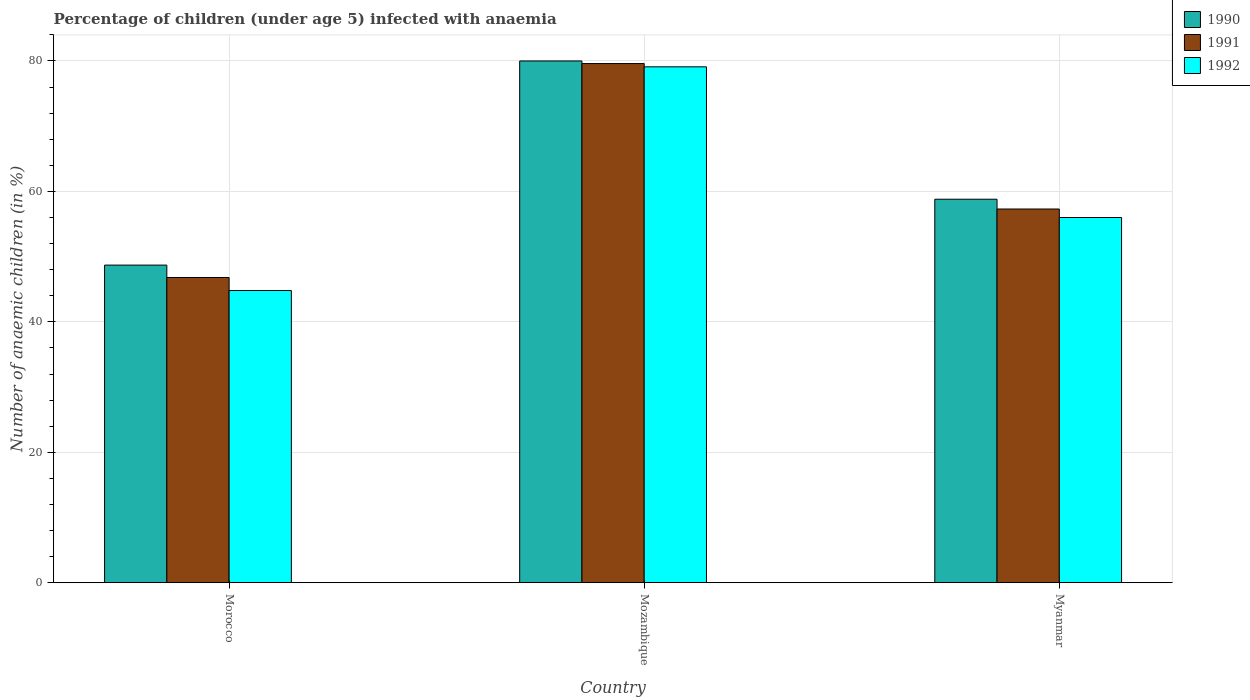How many groups of bars are there?
Your response must be concise. 3. Are the number of bars on each tick of the X-axis equal?
Provide a succinct answer. Yes. How many bars are there on the 1st tick from the right?
Your answer should be compact. 3. What is the label of the 2nd group of bars from the left?
Your answer should be very brief. Mozambique. What is the percentage of children infected with anaemia in in 1992 in Mozambique?
Keep it short and to the point. 79.1. Across all countries, what is the maximum percentage of children infected with anaemia in in 1992?
Make the answer very short. 79.1. Across all countries, what is the minimum percentage of children infected with anaemia in in 1991?
Ensure brevity in your answer.  46.8. In which country was the percentage of children infected with anaemia in in 1991 maximum?
Your answer should be very brief. Mozambique. In which country was the percentage of children infected with anaemia in in 1990 minimum?
Your response must be concise. Morocco. What is the total percentage of children infected with anaemia in in 1992 in the graph?
Offer a very short reply. 179.9. What is the difference between the percentage of children infected with anaemia in in 1990 in Morocco and that in Mozambique?
Give a very brief answer. -31.3. What is the difference between the percentage of children infected with anaemia in in 1990 in Myanmar and the percentage of children infected with anaemia in in 1992 in Mozambique?
Ensure brevity in your answer.  -20.3. What is the average percentage of children infected with anaemia in in 1992 per country?
Make the answer very short. 59.97. What is the difference between the percentage of children infected with anaemia in of/in 1990 and percentage of children infected with anaemia in of/in 1992 in Myanmar?
Your response must be concise. 2.8. What is the ratio of the percentage of children infected with anaemia in in 1992 in Morocco to that in Mozambique?
Your answer should be compact. 0.57. Is the percentage of children infected with anaemia in in 1992 in Morocco less than that in Myanmar?
Your answer should be very brief. Yes. Is the difference between the percentage of children infected with anaemia in in 1990 in Morocco and Mozambique greater than the difference between the percentage of children infected with anaemia in in 1992 in Morocco and Mozambique?
Keep it short and to the point. Yes. What is the difference between the highest and the second highest percentage of children infected with anaemia in in 1990?
Provide a short and direct response. 21.2. What is the difference between the highest and the lowest percentage of children infected with anaemia in in 1991?
Provide a short and direct response. 32.8. Is it the case that in every country, the sum of the percentage of children infected with anaemia in in 1992 and percentage of children infected with anaemia in in 1991 is greater than the percentage of children infected with anaemia in in 1990?
Your response must be concise. Yes. Are all the bars in the graph horizontal?
Offer a very short reply. No. How many countries are there in the graph?
Your response must be concise. 3. Does the graph contain any zero values?
Your answer should be very brief. No. What is the title of the graph?
Ensure brevity in your answer.  Percentage of children (under age 5) infected with anaemia. Does "2007" appear as one of the legend labels in the graph?
Provide a succinct answer. No. What is the label or title of the X-axis?
Provide a succinct answer. Country. What is the label or title of the Y-axis?
Your answer should be very brief. Number of anaemic children (in %). What is the Number of anaemic children (in %) in 1990 in Morocco?
Provide a short and direct response. 48.7. What is the Number of anaemic children (in %) of 1991 in Morocco?
Keep it short and to the point. 46.8. What is the Number of anaemic children (in %) in 1992 in Morocco?
Your answer should be very brief. 44.8. What is the Number of anaemic children (in %) of 1990 in Mozambique?
Give a very brief answer. 80. What is the Number of anaemic children (in %) in 1991 in Mozambique?
Give a very brief answer. 79.6. What is the Number of anaemic children (in %) of 1992 in Mozambique?
Provide a short and direct response. 79.1. What is the Number of anaemic children (in %) in 1990 in Myanmar?
Provide a short and direct response. 58.8. What is the Number of anaemic children (in %) of 1991 in Myanmar?
Your response must be concise. 57.3. Across all countries, what is the maximum Number of anaemic children (in %) of 1991?
Your answer should be compact. 79.6. Across all countries, what is the maximum Number of anaemic children (in %) of 1992?
Keep it short and to the point. 79.1. Across all countries, what is the minimum Number of anaemic children (in %) of 1990?
Your answer should be compact. 48.7. Across all countries, what is the minimum Number of anaemic children (in %) of 1991?
Offer a terse response. 46.8. Across all countries, what is the minimum Number of anaemic children (in %) of 1992?
Keep it short and to the point. 44.8. What is the total Number of anaemic children (in %) in 1990 in the graph?
Your answer should be compact. 187.5. What is the total Number of anaemic children (in %) in 1991 in the graph?
Your response must be concise. 183.7. What is the total Number of anaemic children (in %) of 1992 in the graph?
Provide a short and direct response. 179.9. What is the difference between the Number of anaemic children (in %) in 1990 in Morocco and that in Mozambique?
Provide a short and direct response. -31.3. What is the difference between the Number of anaemic children (in %) of 1991 in Morocco and that in Mozambique?
Offer a very short reply. -32.8. What is the difference between the Number of anaemic children (in %) in 1992 in Morocco and that in Mozambique?
Provide a succinct answer. -34.3. What is the difference between the Number of anaemic children (in %) in 1990 in Mozambique and that in Myanmar?
Keep it short and to the point. 21.2. What is the difference between the Number of anaemic children (in %) of 1991 in Mozambique and that in Myanmar?
Offer a very short reply. 22.3. What is the difference between the Number of anaemic children (in %) of 1992 in Mozambique and that in Myanmar?
Offer a terse response. 23.1. What is the difference between the Number of anaemic children (in %) in 1990 in Morocco and the Number of anaemic children (in %) in 1991 in Mozambique?
Make the answer very short. -30.9. What is the difference between the Number of anaemic children (in %) of 1990 in Morocco and the Number of anaemic children (in %) of 1992 in Mozambique?
Provide a short and direct response. -30.4. What is the difference between the Number of anaemic children (in %) in 1991 in Morocco and the Number of anaemic children (in %) in 1992 in Mozambique?
Offer a very short reply. -32.3. What is the difference between the Number of anaemic children (in %) of 1990 in Mozambique and the Number of anaemic children (in %) of 1991 in Myanmar?
Provide a short and direct response. 22.7. What is the difference between the Number of anaemic children (in %) in 1990 in Mozambique and the Number of anaemic children (in %) in 1992 in Myanmar?
Your answer should be compact. 24. What is the difference between the Number of anaemic children (in %) in 1991 in Mozambique and the Number of anaemic children (in %) in 1992 in Myanmar?
Offer a terse response. 23.6. What is the average Number of anaemic children (in %) of 1990 per country?
Provide a succinct answer. 62.5. What is the average Number of anaemic children (in %) of 1991 per country?
Offer a very short reply. 61.23. What is the average Number of anaemic children (in %) in 1992 per country?
Your response must be concise. 59.97. What is the difference between the Number of anaemic children (in %) of 1990 and Number of anaemic children (in %) of 1991 in Morocco?
Make the answer very short. 1.9. What is the difference between the Number of anaemic children (in %) of 1990 and Number of anaemic children (in %) of 1991 in Mozambique?
Keep it short and to the point. 0.4. What is the difference between the Number of anaemic children (in %) in 1990 and Number of anaemic children (in %) in 1992 in Mozambique?
Your response must be concise. 0.9. What is the difference between the Number of anaemic children (in %) in 1991 and Number of anaemic children (in %) in 1992 in Mozambique?
Your answer should be very brief. 0.5. What is the ratio of the Number of anaemic children (in %) in 1990 in Morocco to that in Mozambique?
Offer a very short reply. 0.61. What is the ratio of the Number of anaemic children (in %) in 1991 in Morocco to that in Mozambique?
Make the answer very short. 0.59. What is the ratio of the Number of anaemic children (in %) of 1992 in Morocco to that in Mozambique?
Provide a succinct answer. 0.57. What is the ratio of the Number of anaemic children (in %) in 1990 in Morocco to that in Myanmar?
Provide a short and direct response. 0.83. What is the ratio of the Number of anaemic children (in %) in 1991 in Morocco to that in Myanmar?
Ensure brevity in your answer.  0.82. What is the ratio of the Number of anaemic children (in %) in 1992 in Morocco to that in Myanmar?
Give a very brief answer. 0.8. What is the ratio of the Number of anaemic children (in %) in 1990 in Mozambique to that in Myanmar?
Your answer should be compact. 1.36. What is the ratio of the Number of anaemic children (in %) of 1991 in Mozambique to that in Myanmar?
Make the answer very short. 1.39. What is the ratio of the Number of anaemic children (in %) of 1992 in Mozambique to that in Myanmar?
Offer a terse response. 1.41. What is the difference between the highest and the second highest Number of anaemic children (in %) of 1990?
Your answer should be very brief. 21.2. What is the difference between the highest and the second highest Number of anaemic children (in %) in 1991?
Your response must be concise. 22.3. What is the difference between the highest and the second highest Number of anaemic children (in %) in 1992?
Give a very brief answer. 23.1. What is the difference between the highest and the lowest Number of anaemic children (in %) in 1990?
Your response must be concise. 31.3. What is the difference between the highest and the lowest Number of anaemic children (in %) of 1991?
Your answer should be compact. 32.8. What is the difference between the highest and the lowest Number of anaemic children (in %) of 1992?
Your answer should be compact. 34.3. 